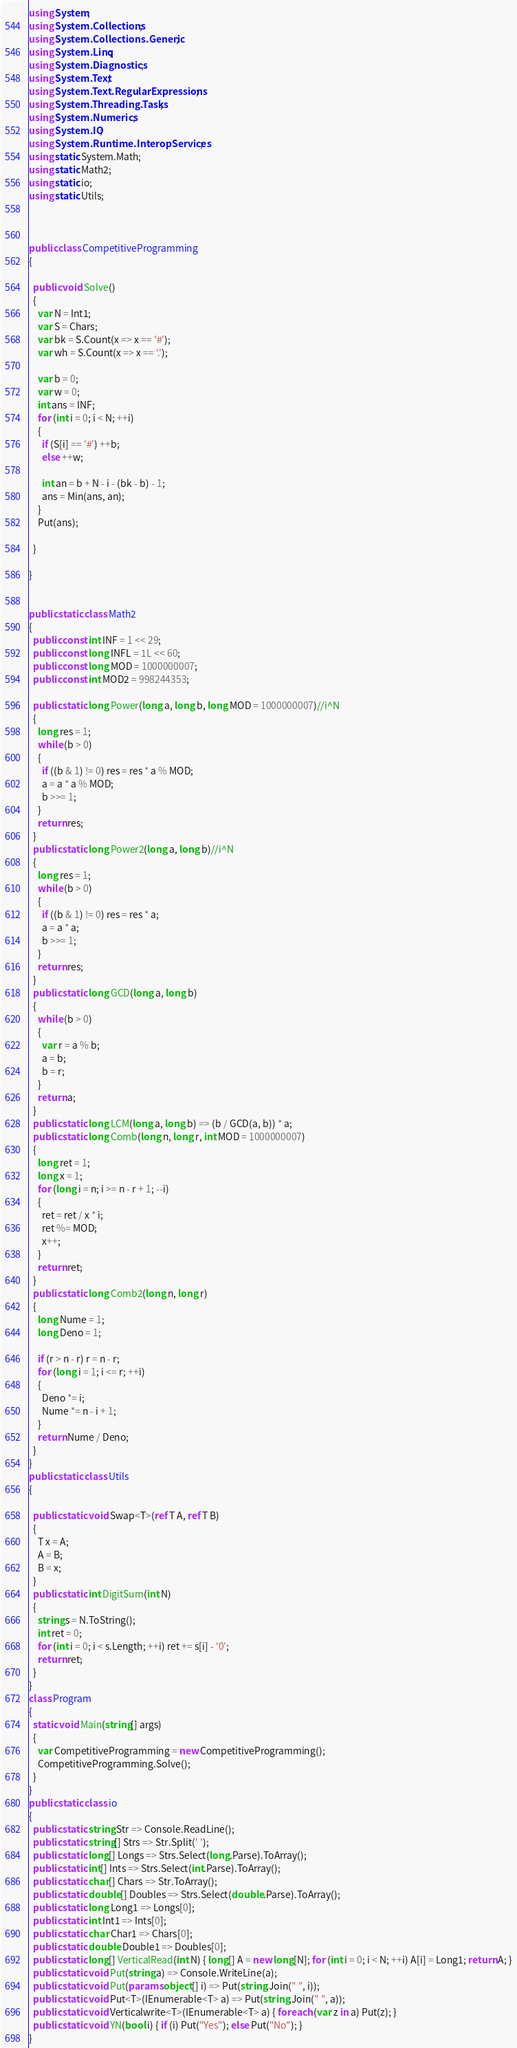<code> <loc_0><loc_0><loc_500><loc_500><_C#_>using System;
using System.Collections;
using System.Collections.Generic;
using System.Linq;
using System.Diagnostics;
using System.Text;
using System.Text.RegularExpressions;
using System.Threading.Tasks;
using System.Numerics;
using System.IO;
using System.Runtime.InteropServices;
using static System.Math;
using static Math2;
using static io;
using static Utils;



public class CompetitiveProgramming
{

  public void Solve()
  {
    var N = Int1;
    var S = Chars;
    var bk = S.Count(x => x == '#');
    var wh = S.Count(x => x == '.');

    var b = 0;
    var w = 0;
    int ans = INF;
    for (int i = 0; i < N; ++i)
    {
      if (S[i] == '#') ++b;
      else ++w;

      int an = b + N - i - (bk - b) - 1;
      ans = Min(ans, an);
    }
    Put(ans);

  }

}


public static class Math2
{
  public const int INF = 1 << 29;
  public const long INFL = 1L << 60;
  public const long MOD = 1000000007;
  public const int MOD2 = 998244353;

  public static long Power(long a, long b, long MOD = 1000000007)//i^N
  {
    long res = 1;
    while (b > 0)
    {
      if ((b & 1) != 0) res = res * a % MOD;
      a = a * a % MOD;
      b >>= 1;
    }
    return res;
  }
  public static long Power2(long a, long b)//i^N
  {
    long res = 1;
    while (b > 0)
    {
      if ((b & 1) != 0) res = res * a;
      a = a * a;
      b >>= 1;
    }
    return res;
  }
  public static long GCD(long a, long b)
  {
    while (b > 0)
    {
      var r = a % b;
      a = b;
      b = r;
    }
    return a;
  }
  public static long LCM(long a, long b) => (b / GCD(a, b)) * a;
  public static long Comb(long n, long r, int MOD = 1000000007)
  {
    long ret = 1;
    long x = 1;
    for (long i = n; i >= n - r + 1; --i)
    {
      ret = ret / x * i;
      ret %= MOD;
      x++;
    }
    return ret;
  }
  public static long Comb2(long n, long r)
  {
    long Nume = 1;
    long Deno = 1;

    if (r > n - r) r = n - r;
    for (long i = 1; i <= r; ++i)
    {
      Deno *= i;
      Nume *= n - i + 1;
    }
    return Nume / Deno;
  }
}
public static class Utils
{

  public static void Swap<T>(ref T A, ref T B)
  {
    T x = A;
    A = B;
    B = x;
  }
  public static int DigitSum(int N)
  {
    string s = N.ToString();
    int ret = 0;
    for (int i = 0; i < s.Length; ++i) ret += s[i] - '0';
    return ret;
  }
}
class Program
{
  static void Main(string[] args)
  {
    var CompetitiveProgramming = new CompetitiveProgramming();
    CompetitiveProgramming.Solve();
  }
}
public static class io
{
  public static string Str => Console.ReadLine();
  public static string[] Strs => Str.Split(' ');
  public static long[] Longs => Strs.Select(long.Parse).ToArray();
  public static int[] Ints => Strs.Select(int.Parse).ToArray();
  public static char[] Chars => Str.ToArray();
  public static double[] Doubles => Strs.Select(double.Parse).ToArray();
  public static long Long1 => Longs[0];
  public static int Int1 => Ints[0];
  public static char Char1 => Chars[0];
  public static double Double1 => Doubles[0];
  public static long[] VerticalRead(int N) { long[] A = new long[N]; for (int i = 0; i < N; ++i) A[i] = Long1; return A; }
  public static void Put(string a) => Console.WriteLine(a);
  public static void Put(params object[] i) => Put(string.Join(" ", i));
  public static void Put<T>(IEnumerable<T> a) => Put(string.Join(" ", a));
  public static void Verticalwrite<T>(IEnumerable<T> a) { foreach (var z in a) Put(z); }
  public static void YN(bool i) { if (i) Put("Yes"); else Put("No"); }
}</code> 